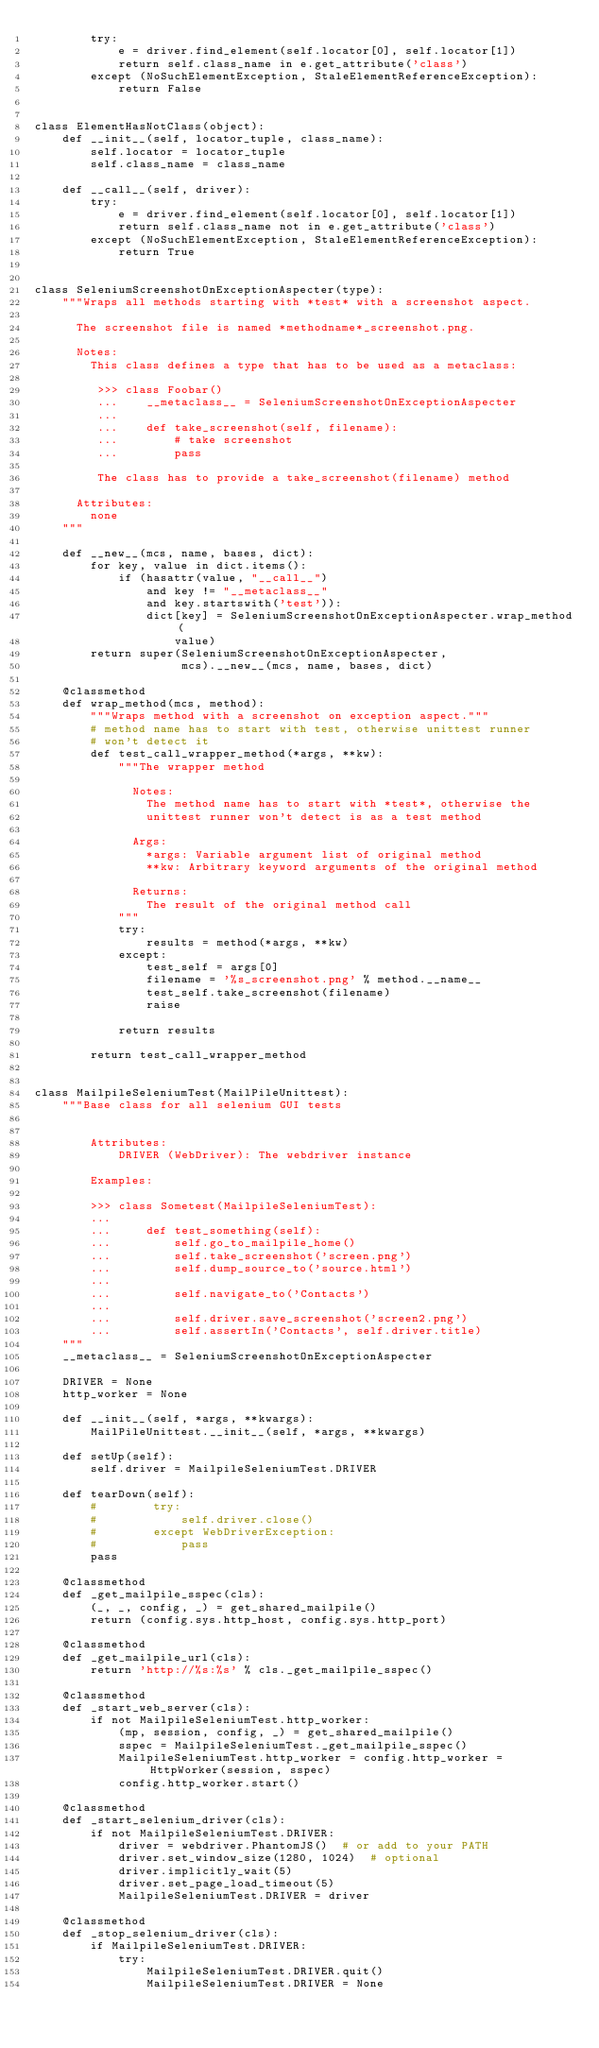Convert code to text. <code><loc_0><loc_0><loc_500><loc_500><_Python_>        try:
            e = driver.find_element(self.locator[0], self.locator[1])
            return self.class_name in e.get_attribute('class')
        except (NoSuchElementException, StaleElementReferenceException):
            return False


class ElementHasNotClass(object):
    def __init__(self, locator_tuple, class_name):
        self.locator = locator_tuple
        self.class_name = class_name

    def __call__(self, driver):
        try:
            e = driver.find_element(self.locator[0], self.locator[1])
            return self.class_name not in e.get_attribute('class')
        except (NoSuchElementException, StaleElementReferenceException):
            return True


class SeleniumScreenshotOnExceptionAspecter(type):
    """Wraps all methods starting with *test* with a screenshot aspect.

      The screenshot file is named *methodname*_screenshot.png.

      Notes:
        This class defines a type that has to be used as a metaclass:

         >>> class Foobar()
         ...    __metaclass__ = SeleniumScreenshotOnExceptionAspecter
         ...
         ...    def take_screenshot(self, filename):
         ...        # take screenshot
         ...        pass

         The class has to provide a take_screenshot(filename) method

      Attributes:
        none
    """

    def __new__(mcs, name, bases, dict):
        for key, value in dict.items():
            if (hasattr(value, "__call__")
                and key != "__metaclass__"
                and key.startswith('test')):
                dict[key] = SeleniumScreenshotOnExceptionAspecter.wrap_method(
                    value)
        return super(SeleniumScreenshotOnExceptionAspecter,
                     mcs).__new__(mcs, name, bases, dict)

    @classmethod
    def wrap_method(mcs, method):
        """Wraps method with a screenshot on exception aspect."""
        # method name has to start with test, otherwise unittest runner
        # won't detect it
        def test_call_wrapper_method(*args, **kw):
            """The wrapper method

              Notes:
                The method name has to start with *test*, otherwise the
                unittest runner won't detect is as a test method

              Args:
                *args: Variable argument list of original method
                **kw: Arbitrary keyword arguments of the original method

              Returns:
                The result of the original method call
            """
            try:
                results = method(*args, **kw)
            except:
                test_self = args[0]
                filename = '%s_screenshot.png' % method.__name__
                test_self.take_screenshot(filename)
                raise

            return results

        return test_call_wrapper_method


class MailpileSeleniumTest(MailPileUnittest):
    """Base class for all selenium GUI tests


        Attributes:
            DRIVER (WebDriver): The webdriver instance

        Examples:

        >>> class Sometest(MailpileSeleniumTest):
        ...
        ...     def test_something(self):
        ...         self.go_to_mailpile_home()
        ...         self.take_screenshot('screen.png')
        ...         self.dump_source_to('source.html')
        ...
        ...         self.navigate_to('Contacts')
        ...
        ...         self.driver.save_screenshot('screen2.png')
        ...         self.assertIn('Contacts', self.driver.title)
    """
    __metaclass__ = SeleniumScreenshotOnExceptionAspecter

    DRIVER = None
    http_worker = None

    def __init__(self, *args, **kwargs):
        MailPileUnittest.__init__(self, *args, **kwargs)

    def setUp(self):
        self.driver = MailpileSeleniumTest.DRIVER

    def tearDown(self):
        #        try:
        #            self.driver.close()
        #        except WebDriverException:
        #            pass
        pass

    @classmethod
    def _get_mailpile_sspec(cls):
        (_, _, config, _) = get_shared_mailpile()
        return (config.sys.http_host, config.sys.http_port)

    @classmethod
    def _get_mailpile_url(cls):
        return 'http://%s:%s' % cls._get_mailpile_sspec()

    @classmethod
    def _start_web_server(cls):
        if not MailpileSeleniumTest.http_worker:
            (mp, session, config, _) = get_shared_mailpile()
            sspec = MailpileSeleniumTest._get_mailpile_sspec()
            MailpileSeleniumTest.http_worker = config.http_worker = HttpWorker(session, sspec)
            config.http_worker.start()

    @classmethod
    def _start_selenium_driver(cls):
        if not MailpileSeleniumTest.DRIVER:
            driver = webdriver.PhantomJS()  # or add to your PATH
            driver.set_window_size(1280, 1024)  # optional
            driver.implicitly_wait(5)
            driver.set_page_load_timeout(5)
            MailpileSeleniumTest.DRIVER = driver

    @classmethod
    def _stop_selenium_driver(cls):
        if MailpileSeleniumTest.DRIVER:
            try:
                MailpileSeleniumTest.DRIVER.quit()
                MailpileSeleniumTest.DRIVER = None</code> 